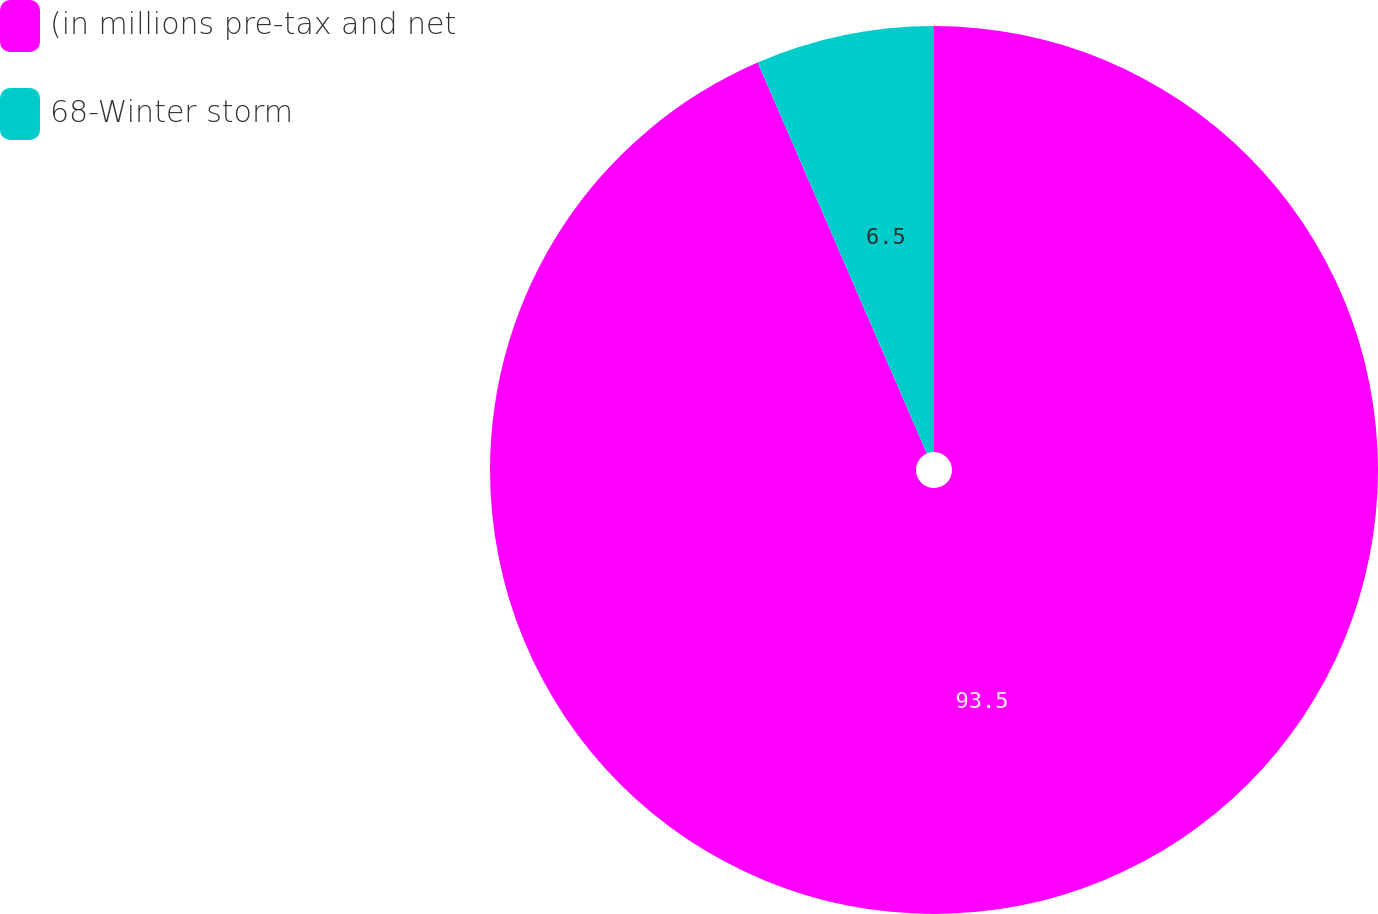<chart> <loc_0><loc_0><loc_500><loc_500><pie_chart><fcel>(in millions pre-tax and net<fcel>68-Winter storm<nl><fcel>93.5%<fcel>6.5%<nl></chart> 